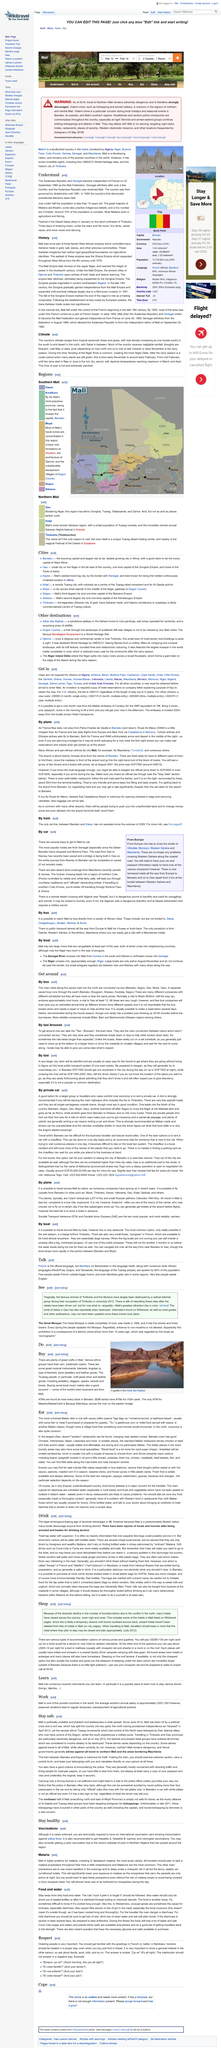Mention a couple of crucial points in this snapshot. The article titled "Understand" states that approximately 90% of the population are not nomadic. On September 22, 1960, the Republic of Senegal achieved independence from France, marking a significant milestone in the country's history. In 1992, the country held its first democratic presidential elections, marking a significant milestone in its democratic history. 